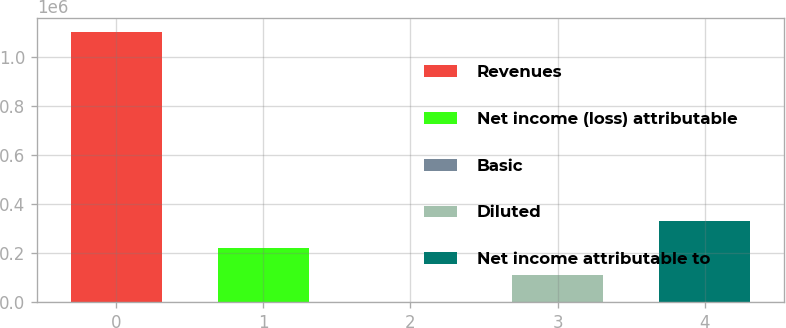Convert chart. <chart><loc_0><loc_0><loc_500><loc_500><bar_chart><fcel>Revenues<fcel>Net income (loss) attributable<fcel>Basic<fcel>Diluted<fcel>Net income attributable to<nl><fcel>1.10426e+06<fcel>220852<fcel>0.31<fcel>110426<fcel>333044<nl></chart> 